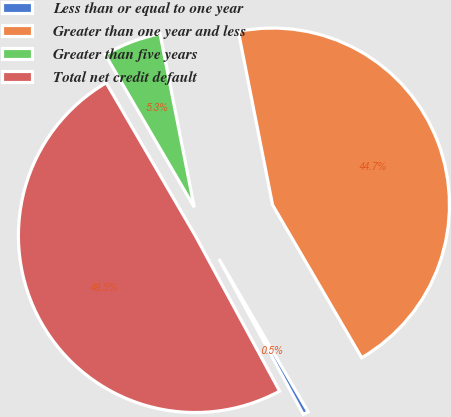Convert chart to OTSL. <chart><loc_0><loc_0><loc_500><loc_500><pie_chart><fcel>Less than or equal to one year<fcel>Greater than one year and less<fcel>Greater than five years<fcel>Total net credit default<nl><fcel>0.49%<fcel>44.7%<fcel>5.3%<fcel>49.51%<nl></chart> 